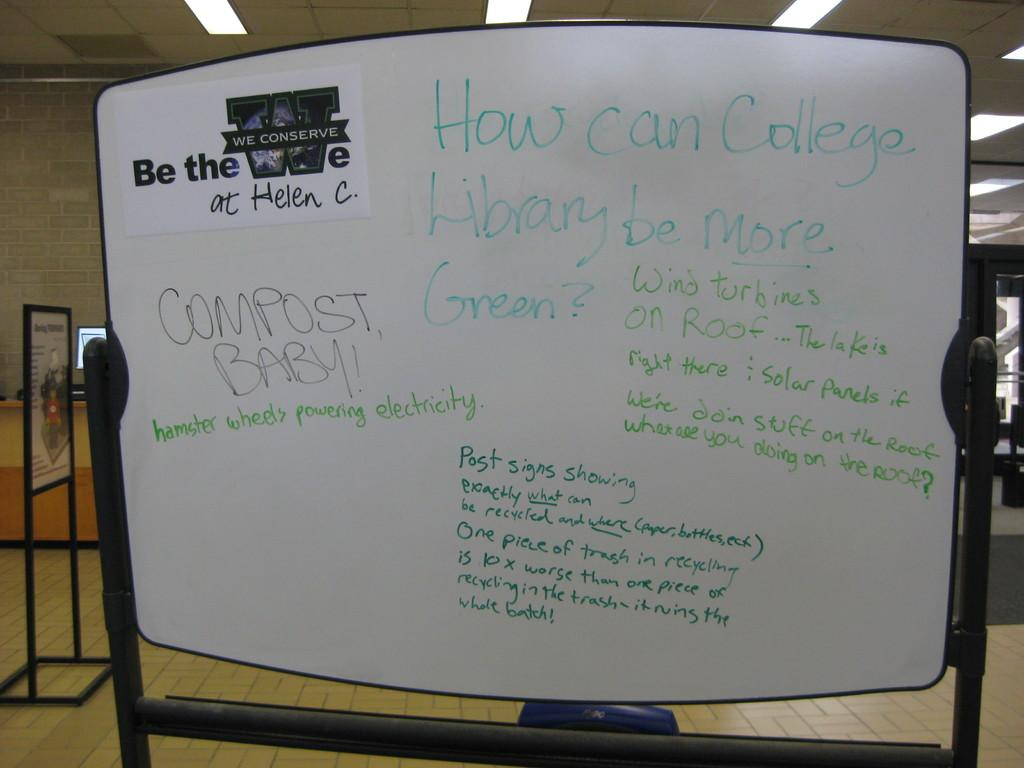Provide a one-sentence caption for the provided image. the word compost is on a white sign. 